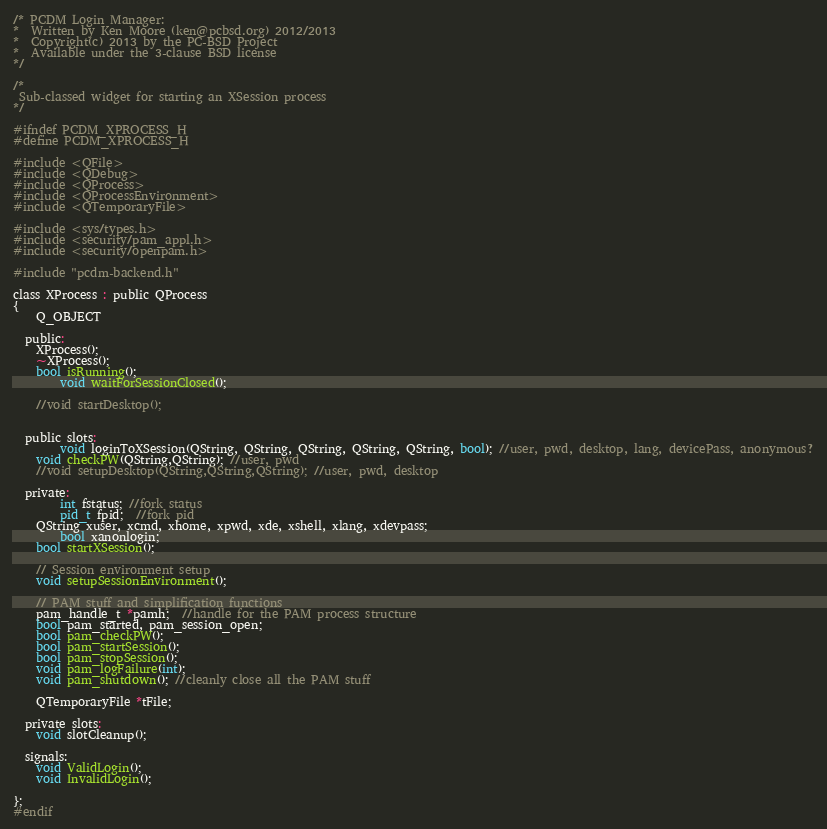Convert code to text. <code><loc_0><loc_0><loc_500><loc_500><_C_>/* PCDM Login Manager:
*  Written by Ken Moore (ken@pcbsd.org) 2012/2013
*  Copyright(c) 2013 by the PC-BSD Project
*  Available under the 3-clause BSD license
*/

/*
 Sub-classed widget for starting an XSession process
*/

#ifndef PCDM_XPROCESS_H
#define PCDM_XPROCESS_H

#include <QFile>
#include <QDebug>
#include <QProcess>
#include <QProcessEnvironment>
#include <QTemporaryFile>

#include <sys/types.h>
#include <security/pam_appl.h>
#include <security/openpam.h>

#include "pcdm-backend.h"

class XProcess : public QProcess
{
	Q_OBJECT

  public:
	XProcess();
	~XProcess();
	bool isRunning();
        void waitForSessionClosed();

	//void startDesktop();


  public slots:
        void loginToXSession(QString, QString, QString, QString, QString, bool); //user, pwd, desktop, lang, devicePass, anonymous?
  	void checkPW(QString,QString); //user, pwd
	//void setupDesktop(QString,QString,QString); //user, pwd, desktop

  private:
        int fstatus; //fork status
        pid_t fpid;  //fork pid
	QString xuser, xcmd, xhome, xpwd, xde, xshell, xlang, xdevpass;
        bool xanonlogin;
  	bool startXSession();

	// Session environment setup
	void setupSessionEnvironment();

	// PAM stuff and simplification functions
	pam_handle_t *pamh;  //handle for the PAM process structure
	bool pam_started, pam_session_open;
	bool pam_checkPW();
	bool pam_startSession();
	bool pam_stopSession();
	void pam_logFailure(int);
  	void pam_shutdown(); //cleanly close all the PAM stuff

	QTemporaryFile *tFile;

  private slots:
  	void slotCleanup();

  signals:
	void ValidLogin();
  	void InvalidLogin();

};
#endif
</code> 